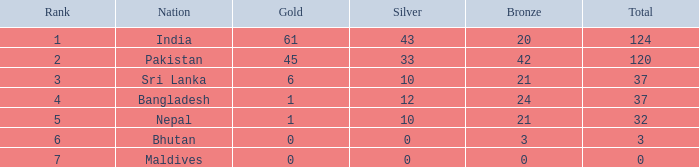How much Rank has a Bronze of 21, and a Silver larger than 10? 0.0. 